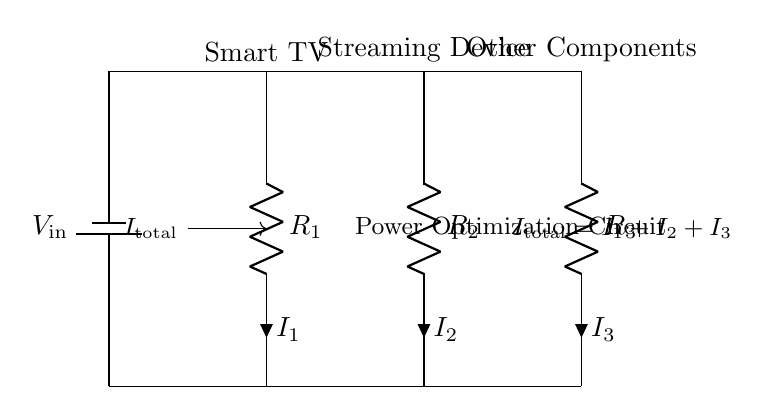What is the input voltage of the circuit? The input voltage is denoted as V_in, which represents the voltage supplied to the circuit from the battery.
Answer: V_in How many resistors are present in the circuit? The circuit diagram shows three resistors labeled as R_1, R_2, and R_3, indicating that there are three resistors total.
Answer: 3 What do the currents I_1, I_2, and I_3 represent? The currents I_1, I_2, and I_3 are the currents flowing through the resistors R_1, R_2, and R_3, respectively, as indicated by the labels on the circuit.
Answer: Currents through R_1, R_2, R_3 What is the relationship between total current and individual currents? The diagram states that the total current, I_total, is the sum of I_1, I_2, and I_3, suggesting that all currents contribute to the total current entering the circuit.
Answer: I_total = I_1 + I_2 + I_3 Which components are connected to the smart TV? The resistor R_1 is connected directly to the smart TV, as shown in the diagram, indicating it is part of the branch associated with the TV.
Answer: R_1 What is the current division principle illustrated in this circuit? The circuit exemplifies the current division principle, where the input current I_total is divided among the three parallel branches, affecting how much current each resistor receives based on its resistance.
Answer: Current division principle 